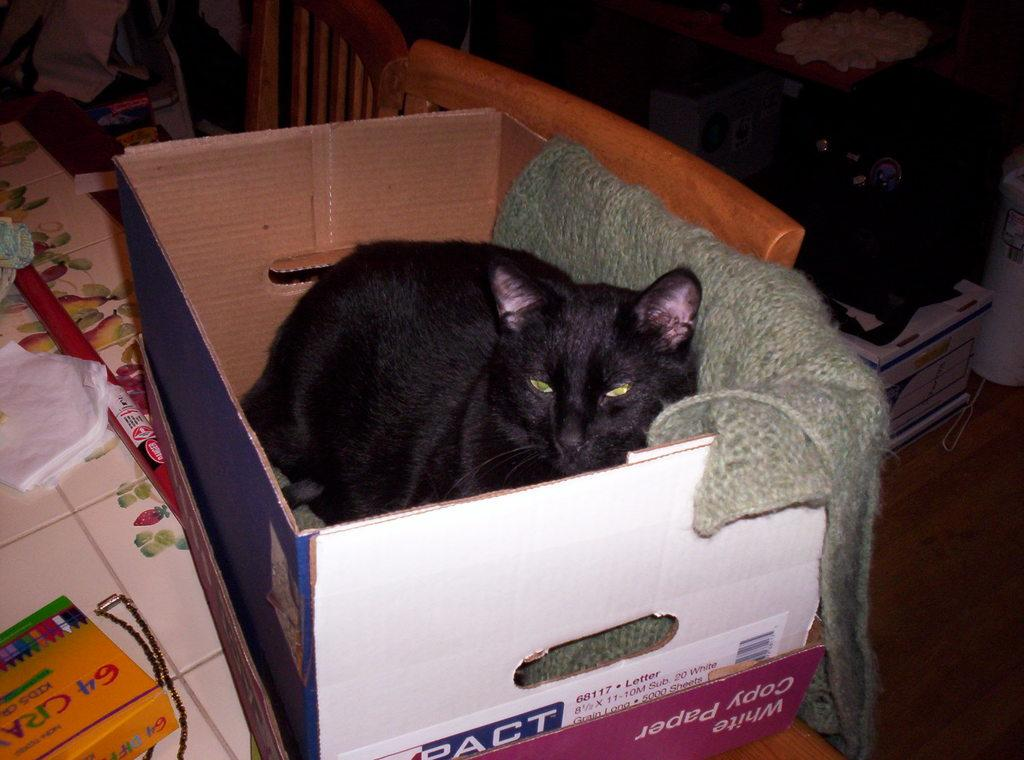<image>
Present a compact description of the photo's key features. A black cat sitting in a box next to a package of 64 crayons. 